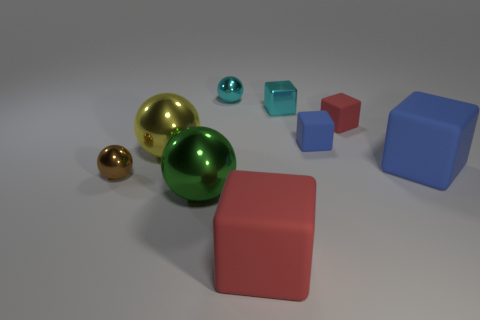Are there any other things that have the same material as the tiny red object?
Your response must be concise. Yes. The big rubber thing behind the metal object to the left of the big ball that is on the left side of the big green sphere is what shape?
Provide a short and direct response. Cube. What is the tiny object that is both to the right of the large yellow object and to the left of the small cyan cube made of?
Your answer should be compact. Metal. There is a big ball that is behind the big blue matte cube in front of the metal thing behind the small cyan block; what color is it?
Your response must be concise. Yellow. How many yellow things are large objects or metal cylinders?
Give a very brief answer. 1. What number of other things are there of the same size as the green metal object?
Provide a short and direct response. 3. How many big red cubes are there?
Keep it short and to the point. 1. Is there anything else that is the same shape as the big blue rubber object?
Offer a terse response. Yes. Is the material of the red block that is in front of the tiny brown ball the same as the tiny thing that is left of the cyan metallic ball?
Ensure brevity in your answer.  No. What is the small brown object made of?
Provide a succinct answer. Metal. 